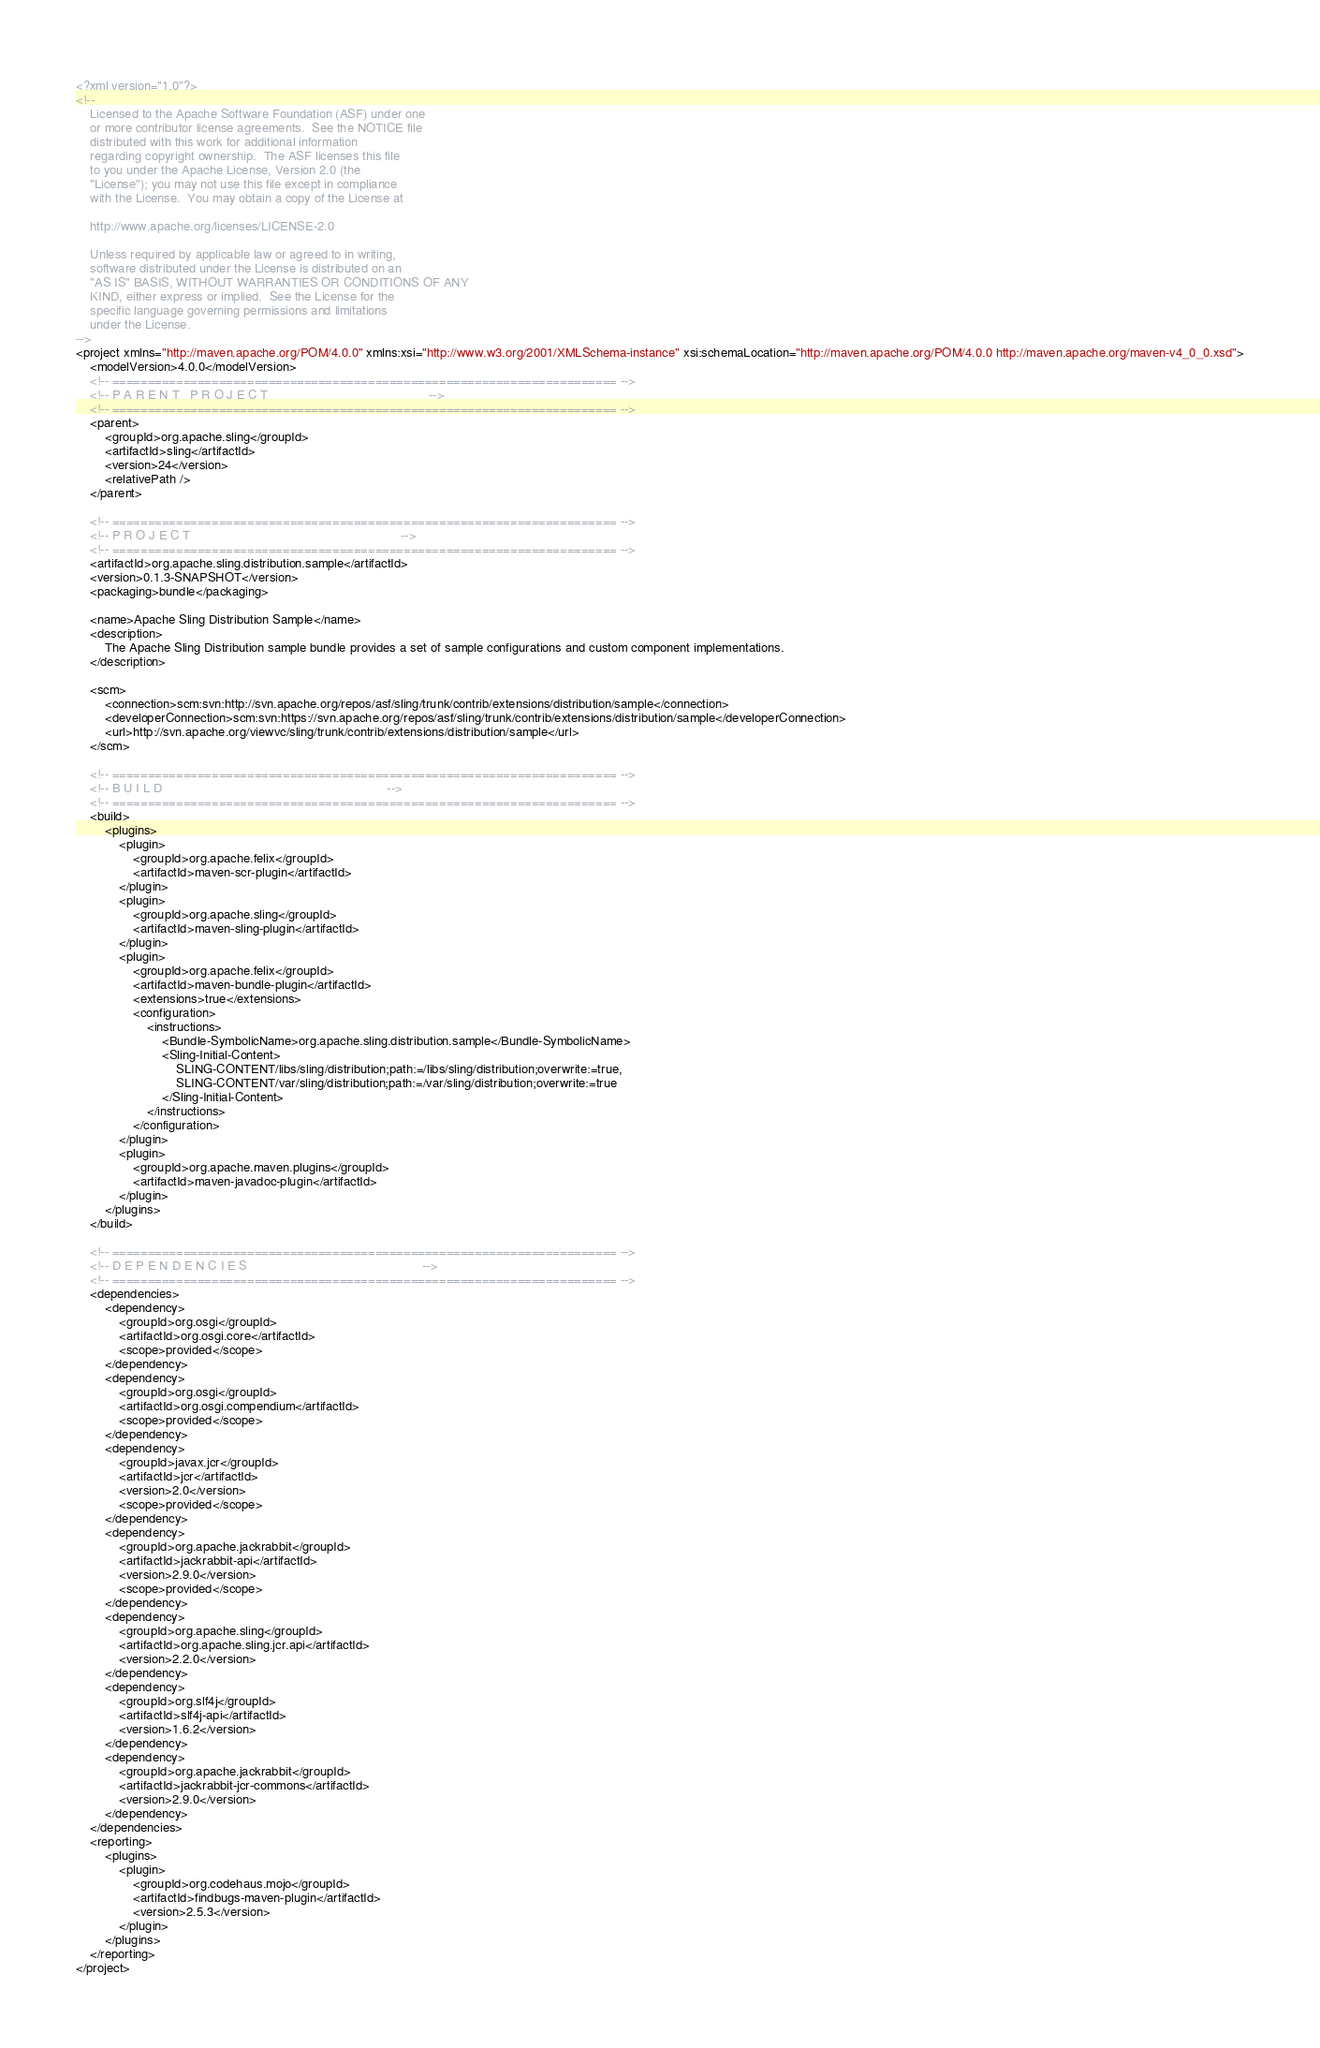Convert code to text. <code><loc_0><loc_0><loc_500><loc_500><_XML_><?xml version="1.0"?>
<!--
    Licensed to the Apache Software Foundation (ASF) under one
    or more contributor license agreements.  See the NOTICE file
    distributed with this work for additional information
    regarding copyright ownership.  The ASF licenses this file
    to you under the Apache License, Version 2.0 (the
    "License"); you may not use this file except in compliance
    with the License.  You may obtain a copy of the License at
    
    http://www.apache.org/licenses/LICENSE-2.0
    
    Unless required by applicable law or agreed to in writing,
    software distributed under the License is distributed on an
    "AS IS" BASIS, WITHOUT WARRANTIES OR CONDITIONS OF ANY
    KIND, either express or implied.  See the License for the
    specific language governing permissions and limitations
    under the License.
-->
<project xmlns="http://maven.apache.org/POM/4.0.0" xmlns:xsi="http://www.w3.org/2001/XMLSchema-instance" xsi:schemaLocation="http://maven.apache.org/POM/4.0.0 http://maven.apache.org/maven-v4_0_0.xsd">
    <modelVersion>4.0.0</modelVersion>
    <!-- ======================================================================= -->
    <!-- P A R E N T   P R O J E C T                                             -->
    <!-- ======================================================================= -->
    <parent>
        <groupId>org.apache.sling</groupId>
        <artifactId>sling</artifactId>
        <version>24</version>
        <relativePath />
    </parent>

    <!-- ======================================================================= -->
    <!-- P R O J E C T                                                           -->
    <!-- ======================================================================= -->
    <artifactId>org.apache.sling.distribution.sample</artifactId>
    <version>0.1.3-SNAPSHOT</version>
    <packaging>bundle</packaging>

    <name>Apache Sling Distribution Sample</name>
    <description>
        The Apache Sling Distribution sample bundle provides a set of sample configurations and custom component implementations.
    </description>

    <scm>
        <connection>scm:svn:http://svn.apache.org/repos/asf/sling/trunk/contrib/extensions/distribution/sample</connection>
        <developerConnection>scm:svn:https://svn.apache.org/repos/asf/sling/trunk/contrib/extensions/distribution/sample</developerConnection>
        <url>http://svn.apache.org/viewvc/sling/trunk/contrib/extensions/distribution/sample</url>
    </scm>

    <!-- ======================================================================= -->
    <!-- B U I L D                                                               -->
    <!-- ======================================================================= -->
    <build>
        <plugins>
            <plugin>
                <groupId>org.apache.felix</groupId>
                <artifactId>maven-scr-plugin</artifactId>
            </plugin>
            <plugin>
                <groupId>org.apache.sling</groupId>
                <artifactId>maven-sling-plugin</artifactId>
            </plugin>
            <plugin>
                <groupId>org.apache.felix</groupId>
                <artifactId>maven-bundle-plugin</artifactId>
                <extensions>true</extensions>
                <configuration>
                    <instructions>
                        <Bundle-SymbolicName>org.apache.sling.distribution.sample</Bundle-SymbolicName>
                        <Sling-Initial-Content>
                            SLING-CONTENT/libs/sling/distribution;path:=/libs/sling/distribution;overwrite:=true,
                            SLING-CONTENT/var/sling/distribution;path:=/var/sling/distribution;overwrite:=true
                        </Sling-Initial-Content>
                    </instructions>
                </configuration>
            </plugin>
            <plugin>
                <groupId>org.apache.maven.plugins</groupId>
                <artifactId>maven-javadoc-plugin</artifactId>
            </plugin>
        </plugins>
    </build>

    <!-- ======================================================================= -->
    <!-- D E P E N D E N C I E S                                                 -->
    <!-- ======================================================================= -->
    <dependencies>
        <dependency>
            <groupId>org.osgi</groupId>
            <artifactId>org.osgi.core</artifactId>
            <scope>provided</scope>
        </dependency>
        <dependency>
            <groupId>org.osgi</groupId>
            <artifactId>org.osgi.compendium</artifactId>
            <scope>provided</scope>
        </dependency>
        <dependency>
            <groupId>javax.jcr</groupId>
            <artifactId>jcr</artifactId>
            <version>2.0</version>
            <scope>provided</scope>
        </dependency>
        <dependency>
            <groupId>org.apache.jackrabbit</groupId>
            <artifactId>jackrabbit-api</artifactId>
            <version>2.9.0</version>
            <scope>provided</scope>
        </dependency>
        <dependency>
            <groupId>org.apache.sling</groupId>
            <artifactId>org.apache.sling.jcr.api</artifactId>
            <version>2.2.0</version>
        </dependency>
        <dependency>
            <groupId>org.slf4j</groupId>
            <artifactId>slf4j-api</artifactId>
            <version>1.6.2</version>
        </dependency>
        <dependency>
            <groupId>org.apache.jackrabbit</groupId>
            <artifactId>jackrabbit-jcr-commons</artifactId>
            <version>2.9.0</version>
        </dependency>
    </dependencies>
    <reporting>
        <plugins>
            <plugin>
                <groupId>org.codehaus.mojo</groupId>
                <artifactId>findbugs-maven-plugin</artifactId>
                <version>2.5.3</version>
            </plugin>
        </plugins>
    </reporting>
</project>
</code> 